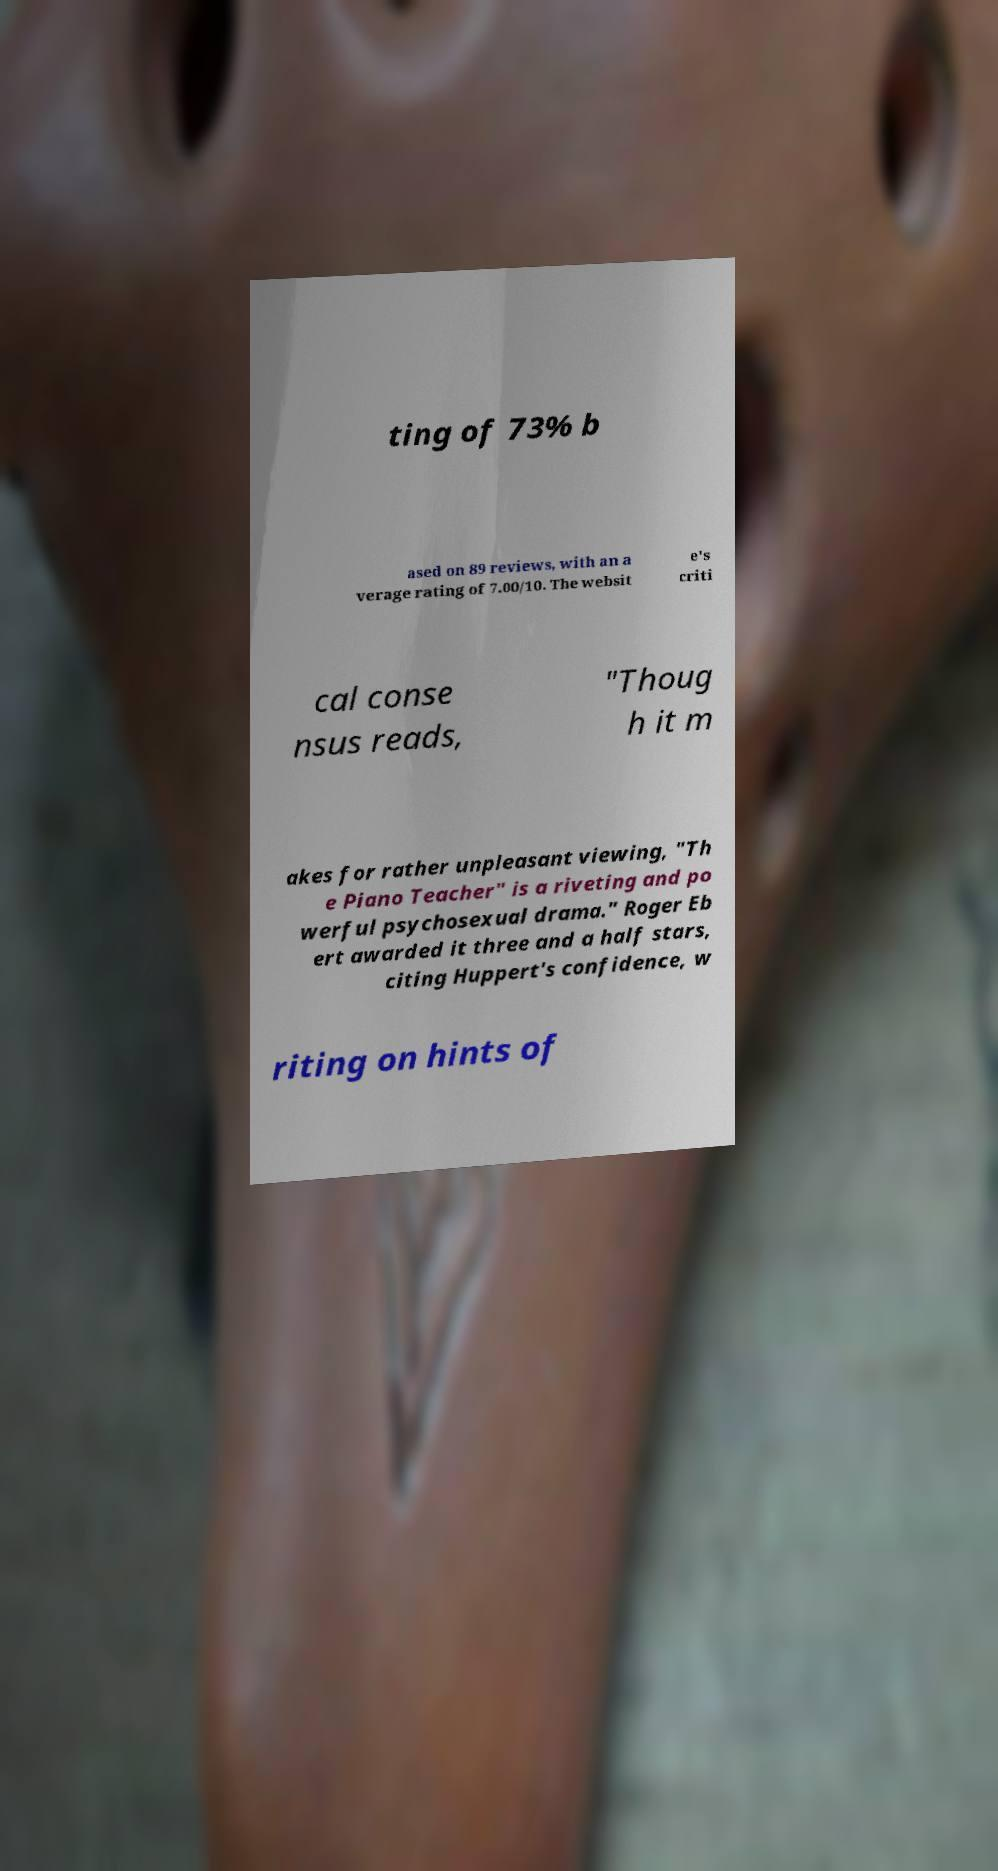Please identify and transcribe the text found in this image. ting of 73% b ased on 89 reviews, with an a verage rating of 7.00/10. The websit e's criti cal conse nsus reads, "Thoug h it m akes for rather unpleasant viewing, "Th e Piano Teacher" is a riveting and po werful psychosexual drama." Roger Eb ert awarded it three and a half stars, citing Huppert's confidence, w riting on hints of 